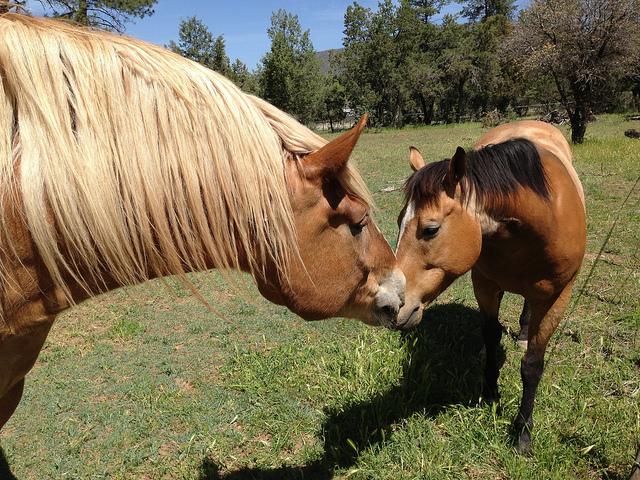Are the horses actually kissing?
Keep it brief. No. Are they in a field?
Concise answer only. Yes. How many animals can be seen?
Keep it brief. 2. Do they have the same color hair?
Concise answer only. No. 